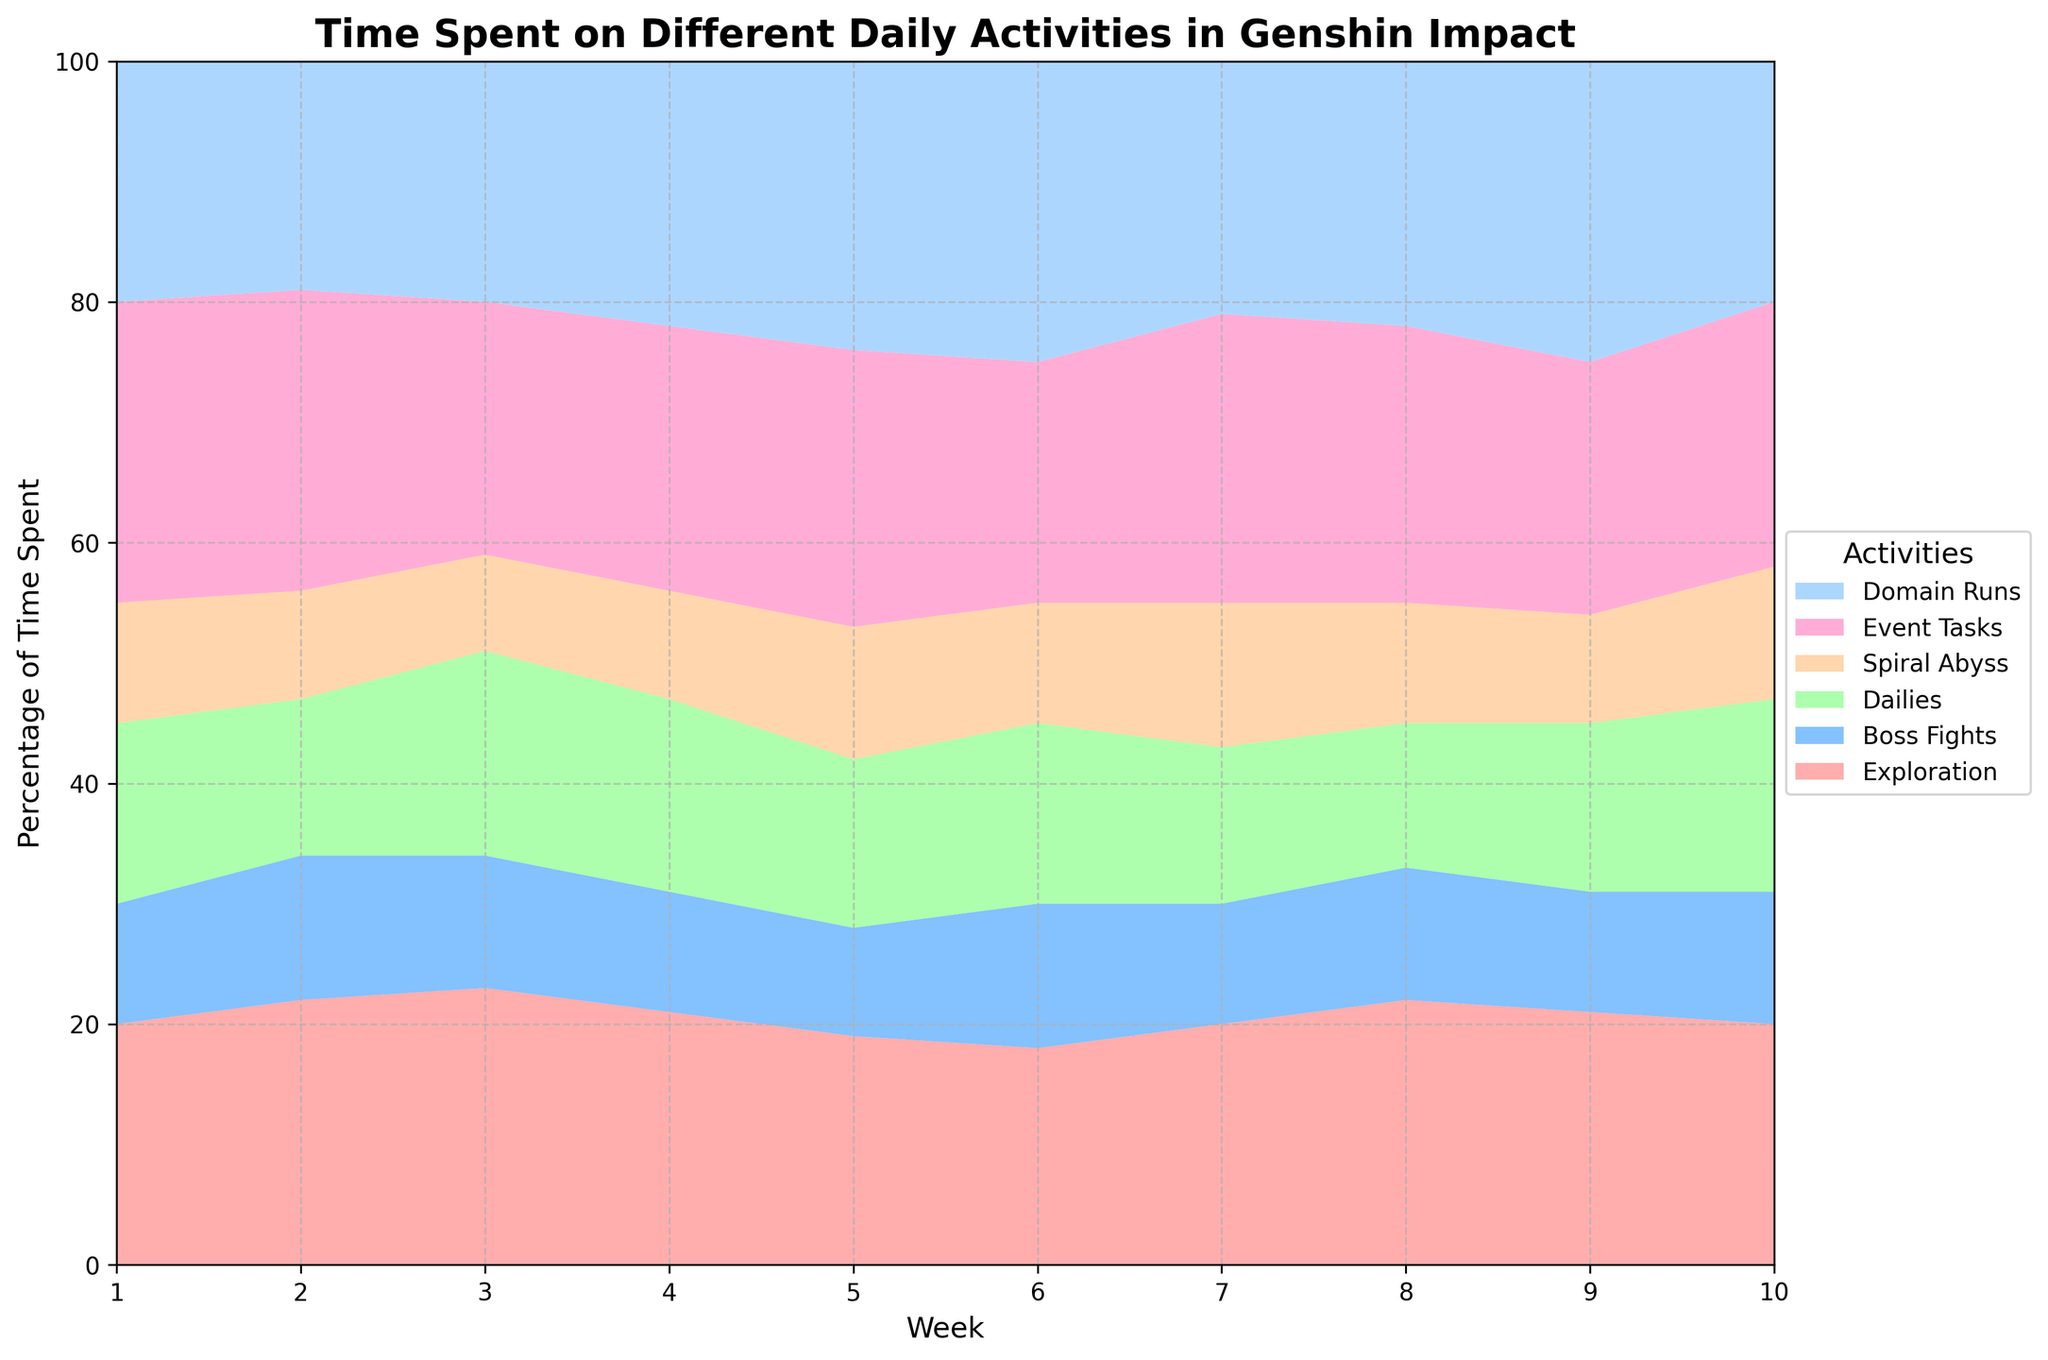what's the title of the chart? Look at the top of the chart where the title is usually located. The title for this chart is "Time Spent on Different Daily Activities in Genshin Impact".
Answer: Time Spent on Different Daily Activities in Genshin Impact how many weeks are displayed on the x-axis? Count the unique tick marks along the x-axis. The ticks range from week 1 to week 10.
Answer: 10 which activity has the smallest percentage in week 4? Look at week 4 and compare the colored areas for the activities. "Boss Fights" has the smallest area.
Answer: Boss Fights how does the percentage of time spent on Domain Runs in week 10 compare to week 5? Identify the areas representing Domain Runs in weeks 5 and 10. In week 10, the area appears smaller compared to week 5.
Answer: Smaller in week 10 what's the difference in the percentage of time spent on Exploration between weeks 3 and 6? Examine the Exploration area in weeks 3 and 6. Subtract week 6's percentage from week 3's. In week 3, Exploration is about 23%, and in week 6, it is about 18%.
Answer: 5% which week had the highest percentage of time spent on Event Tasks? Compare the height (area) of the Event Tasks across all weeks. Week 1 shows the highest percentage.
Answer: Week 1 how did the percentage of time spent on Spiral Abyss change from week 2 to week 9? Analyze the Spiral Abyss areas in weeks 2 and 9. It appears to slightly decrease from approximately 9% in week 2 to about 9% in week 9.
Answer: Decreased if you sum the percentages of Exploration and Boss Fights in week 8, what is the total? Find the percentages for Exploration and Boss Fights in week 8 and add them. Exploration is around 22%, and Boss Fights are approximately 11%.
Answer: 33% is the percentage of time spent on Dailies consistently increasing or decreasing? Observe the trend in the Dailies area across all weeks. The area shows fluctuations but no consistent increase or decrease.
Answer: Neither consistently increasing nor decreasing 